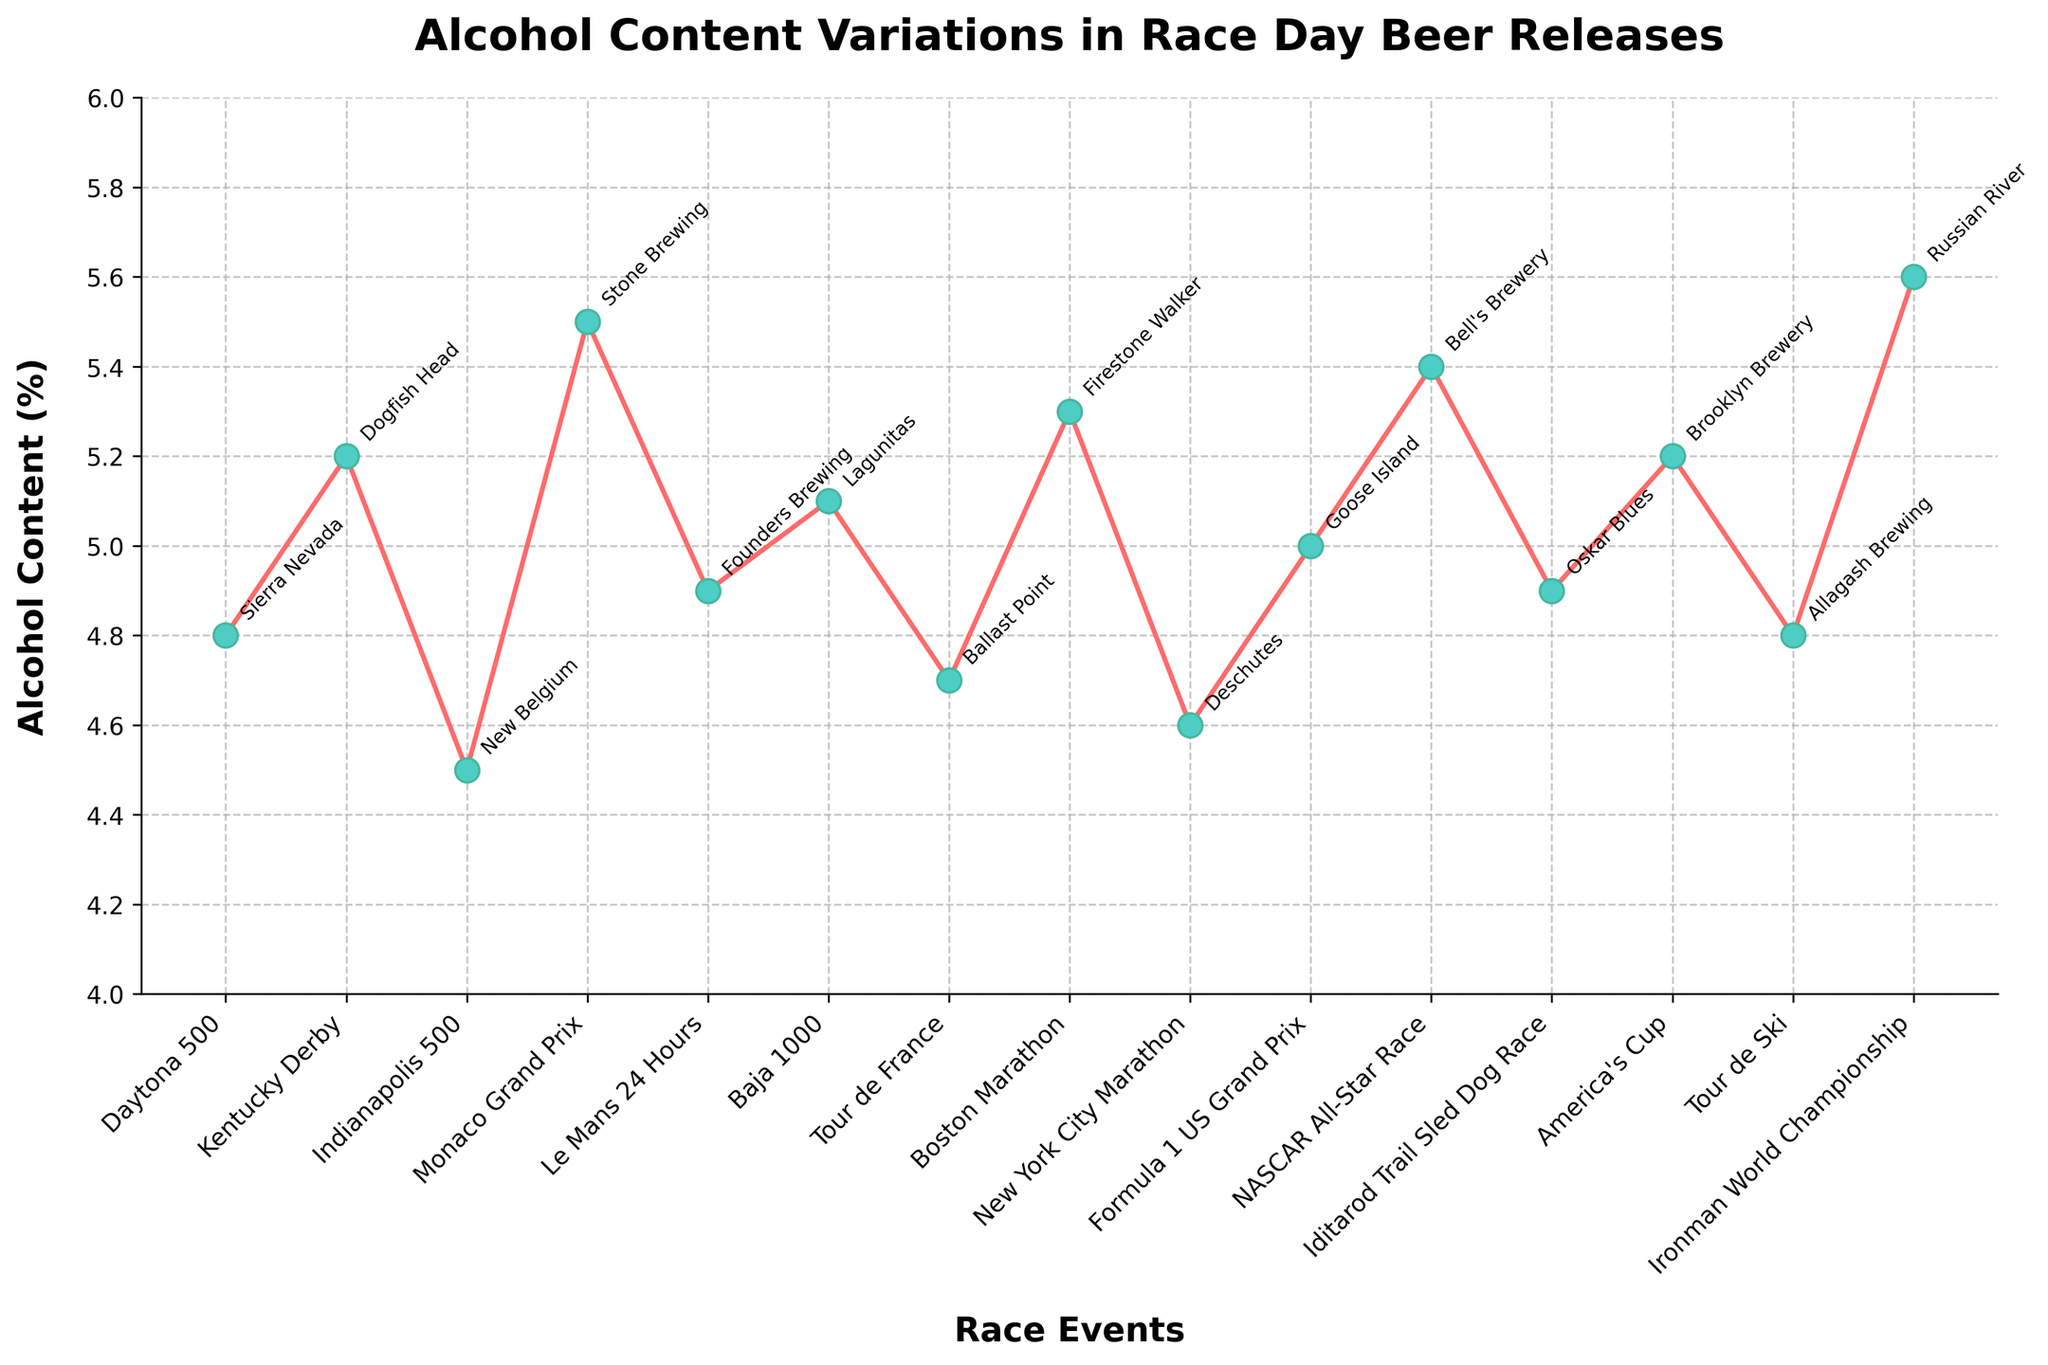What is the range of alcohol content (%) across all breweries? The highest alcohol content is 5.6%, and the lowest is 4.5%. Calculate the range by subtracting the lowest value from the highest: 5.6% - 4.5% = 1.1%.
Answer: 1.1% Which brewery has the highest alcohol content and which race event does it correspond to? The highest alcohol content corresponds to Russian River with an alcohol content of 5.6%, associated with the Ironman World Championship.
Answer: Russian River, Ironman World Championship How many breweries have an alcohol content equal to or greater than 5.0%? By examining the data points above 5.0% on the y-axis, we find the breweries: Dogfish Head, Stone Brewing, Lagunitas, Firestone Walker, Goose Island, Bell's Brewery, Brooklyn Brewery, and Russian River, which totals to 8 breweries.
Answer: 8 Which brewery has the least alcohol content and in which race event was it released? New Belgium has the lowest alcohol content of 4.5%, and it corresponds to the Indianapolis 500 race event.
Answer: New Belgium, Indianapolis 500 What is the average alcohol content (%) of all the beer releases? Sum the alcohol content of all beer releases and divide by the number of data points: (4.8 + 5.2 + 4.5 + 5.5 + 4.9 + 5.1 + 4.7 + 5.3 + 4.6 + 5.0 + 5.4 + 4.9 + 5.2 + 4.8 + 5.6) / 15 = 74.5 / 15 = 4.97%.
Answer: 4.97% Compare the alcohol contents of the beers released for the Boston Marathon and the New York City Marathon. Which one is higher? The Boston Marathon beer release has an alcohol content of 5.3%, while the New York City Marathon beer release has a content of 4.6%. Therefore, the Boston Marathon beer has a higher alcohol content.
Answer: Boston Marathon Which race event corresponds to an alcohol content of 5.4%, and which brewery produced it? An alcohol content of 5.4% is associated with the NASCAR All-Star Race, and the beer was produced by Bell's Brewery.
Answer: NASCAR All-Star Race, Bell's Brewery What is the difference between the highest and lowest alcohol content percentages? The highest alcohol content is 5.6% (Russian River), and the lowest is 4.5% (New Belgium). The difference is calculated as 5.6% - 4.5% = 1.1%.
Answer: 1.1% Which beer has an alcohol content of 5.0% and what race event does it correspond to? An alcohol content of 5.0% is associated with Goose Island and corresponds to the Formula 1 US Grand Prix event.
Answer: Goose Island, Formula 1 US Grand Prix 